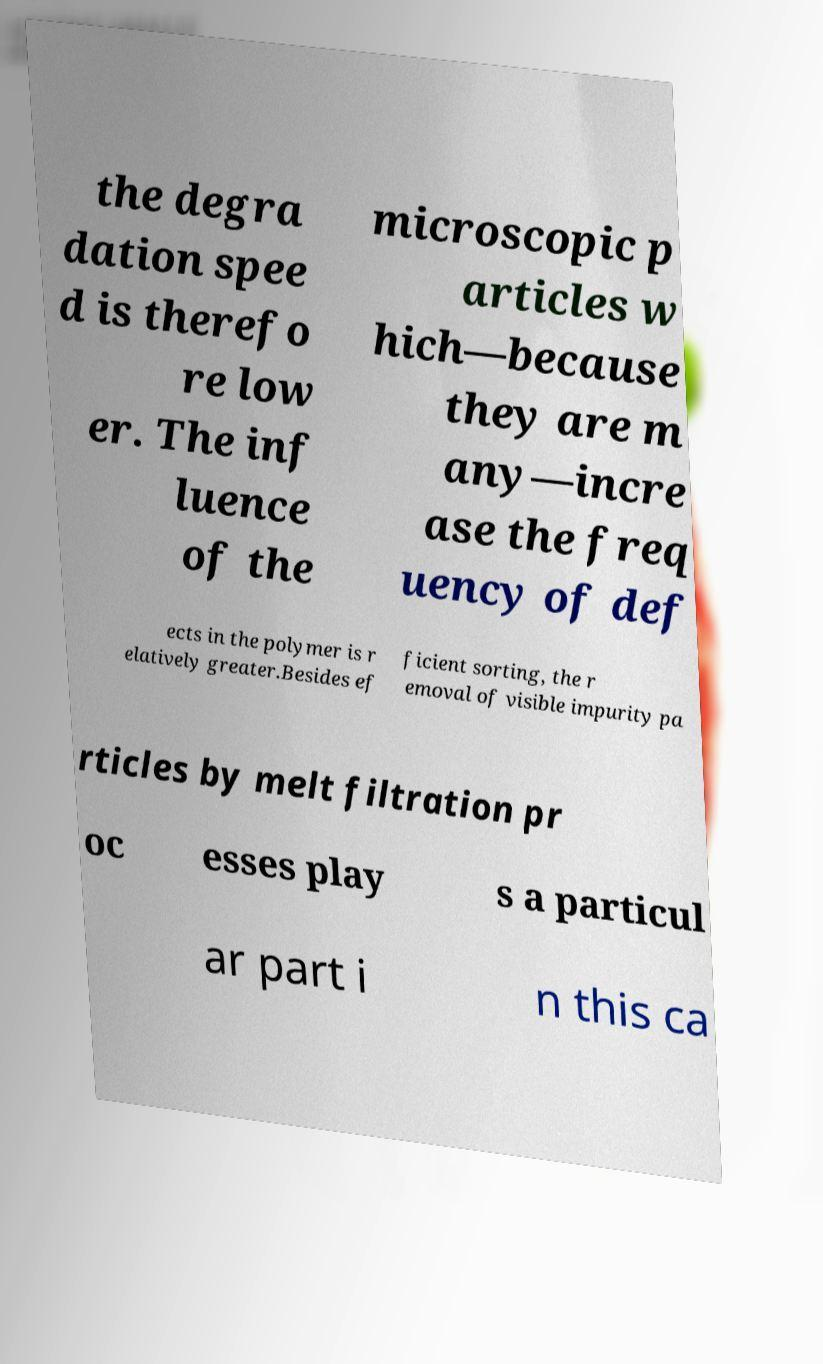Could you extract and type out the text from this image? the degra dation spee d is therefo re low er. The inf luence of the microscopic p articles w hich—because they are m any—incre ase the freq uency of def ects in the polymer is r elatively greater.Besides ef ficient sorting, the r emoval of visible impurity pa rticles by melt filtration pr oc esses play s a particul ar part i n this ca 